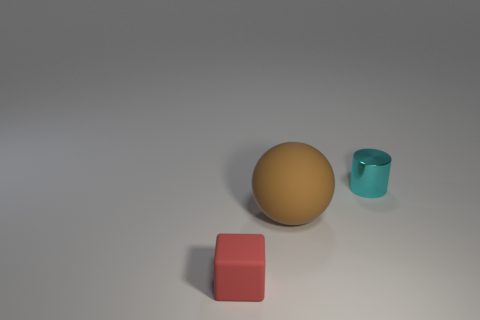Add 3 small matte cylinders. How many objects exist? 6 Subtract all cylinders. How many objects are left? 2 Add 1 large purple metal cylinders. How many large purple metal cylinders exist? 1 Subtract 0 brown cylinders. How many objects are left? 3 Subtract all blue metallic cylinders. Subtract all spheres. How many objects are left? 2 Add 2 small matte blocks. How many small matte blocks are left? 3 